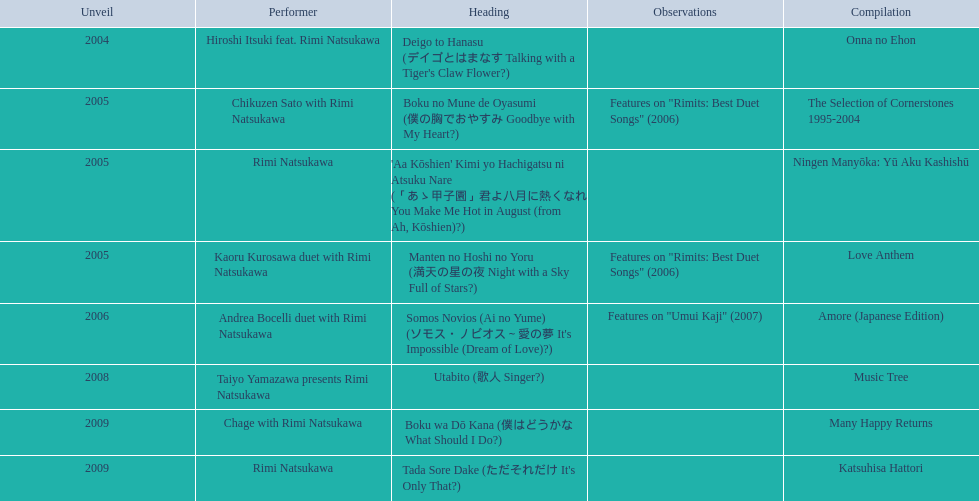What are the notes for sky full of stars? Features on "Rimits: Best Duet Songs" (2006). What other song features this same note? Boku no Mune de Oyasumi (僕の胸でおやすみ Goodbye with My Heart?). 